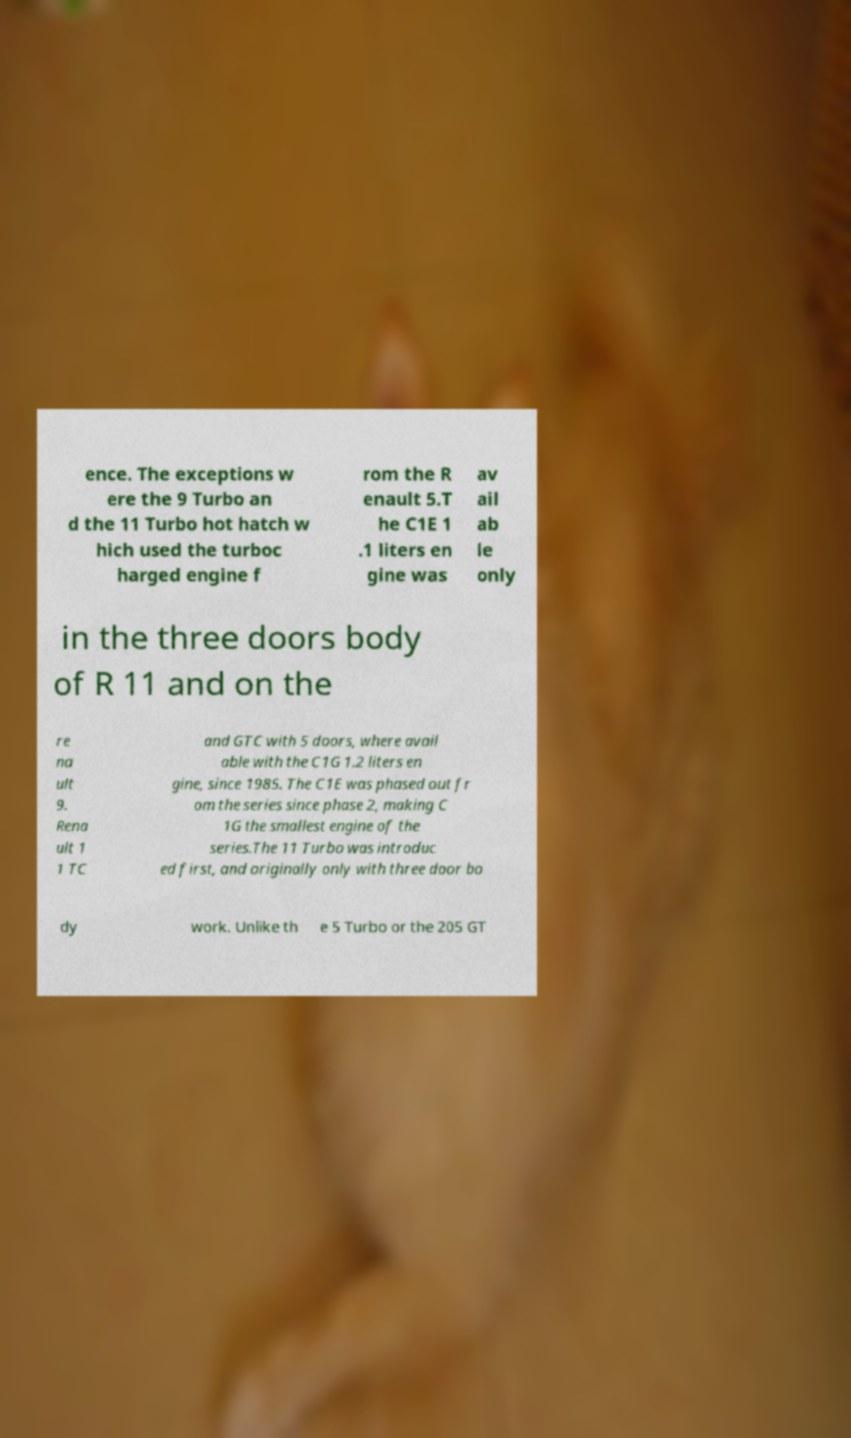I need the written content from this picture converted into text. Can you do that? ence. The exceptions w ere the 9 Turbo an d the 11 Turbo hot hatch w hich used the turboc harged engine f rom the R enault 5.T he C1E 1 .1 liters en gine was av ail ab le only in the three doors body of R 11 and on the re na ult 9. Rena ult 1 1 TC and GTC with 5 doors, where avail able with the C1G 1.2 liters en gine, since 1985. The C1E was phased out fr om the series since phase 2, making C 1G the smallest engine of the series.The 11 Turbo was introduc ed first, and originally only with three door bo dy work. Unlike th e 5 Turbo or the 205 GT 